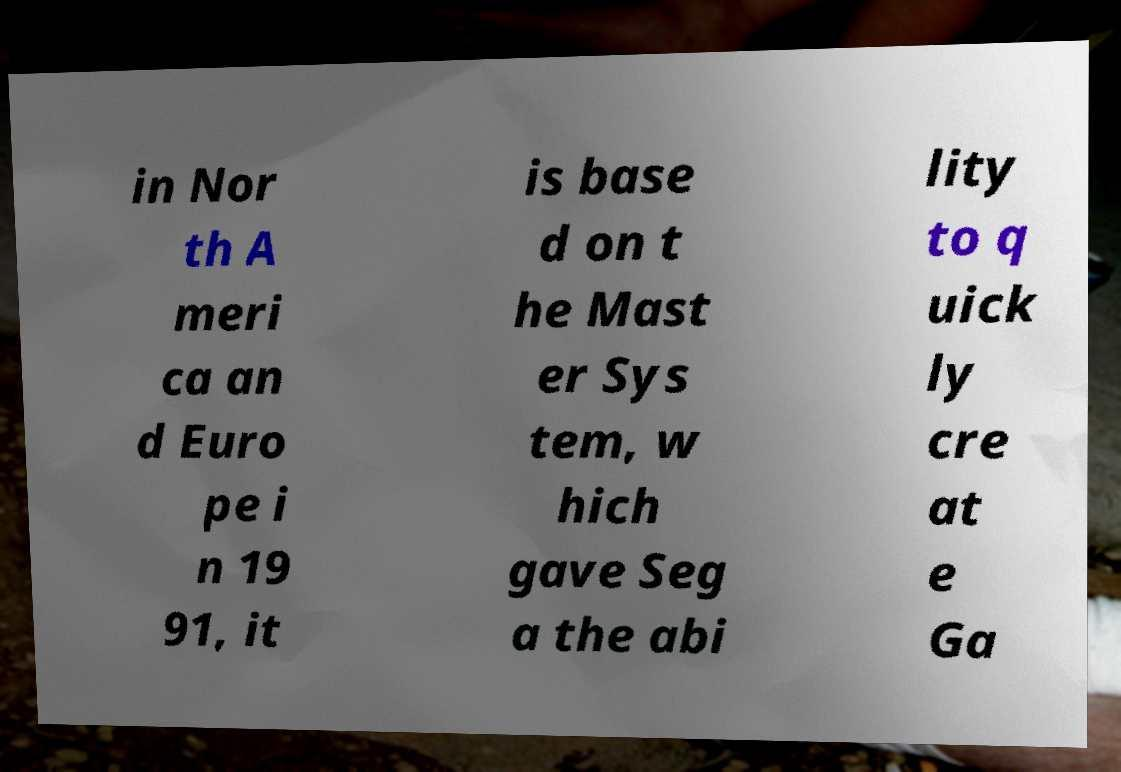I need the written content from this picture converted into text. Can you do that? in Nor th A meri ca an d Euro pe i n 19 91, it is base d on t he Mast er Sys tem, w hich gave Seg a the abi lity to q uick ly cre at e Ga 